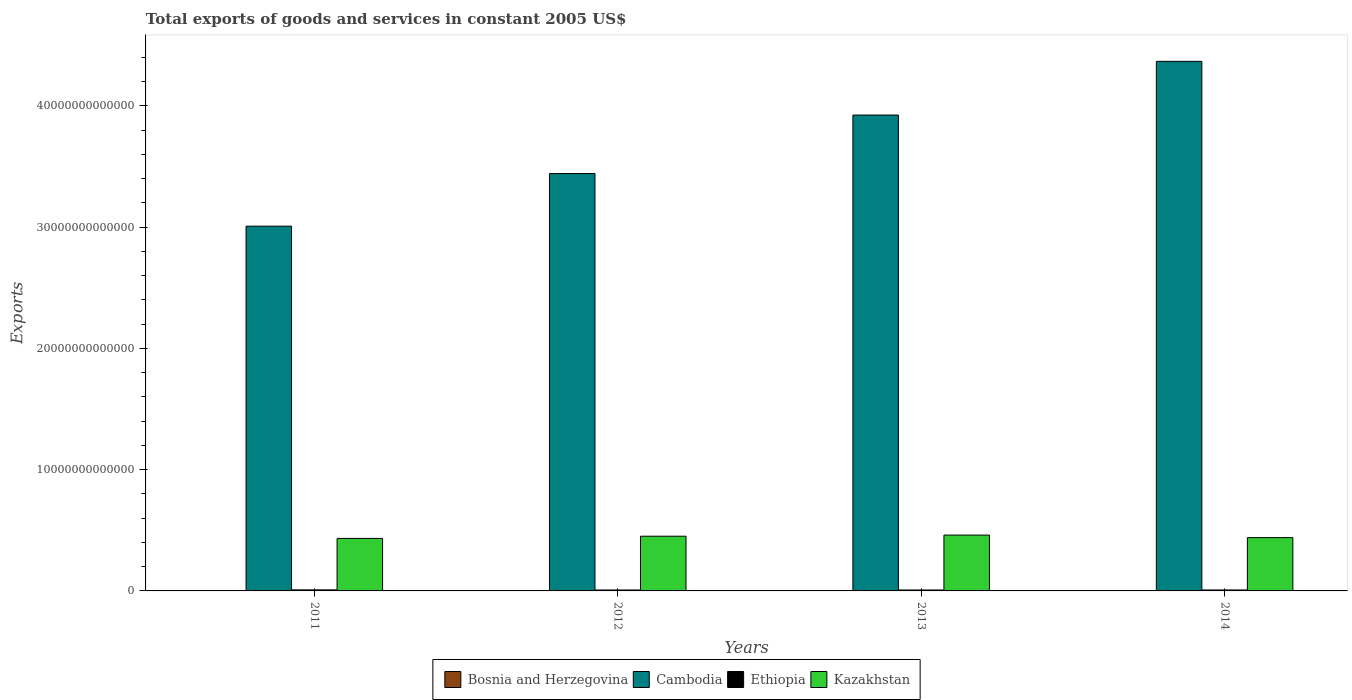How many different coloured bars are there?
Keep it short and to the point. 4. How many groups of bars are there?
Give a very brief answer. 4. Are the number of bars per tick equal to the number of legend labels?
Provide a short and direct response. Yes. How many bars are there on the 2nd tick from the right?
Make the answer very short. 4. What is the total exports of goods and services in Kazakhstan in 2012?
Make the answer very short. 4.51e+12. Across all years, what is the maximum total exports of goods and services in Bosnia and Herzegovina?
Offer a terse response. 8.82e+09. Across all years, what is the minimum total exports of goods and services in Ethiopia?
Your answer should be compact. 7.70e+1. In which year was the total exports of goods and services in Cambodia maximum?
Offer a terse response. 2014. In which year was the total exports of goods and services in Bosnia and Herzegovina minimum?
Your answer should be very brief. 2012. What is the total total exports of goods and services in Bosnia and Herzegovina in the graph?
Give a very brief answer. 3.30e+1. What is the difference between the total exports of goods and services in Cambodia in 2012 and that in 2013?
Your answer should be very brief. -4.83e+12. What is the difference between the total exports of goods and services in Ethiopia in 2012 and the total exports of goods and services in Cambodia in 2013?
Give a very brief answer. -3.92e+13. What is the average total exports of goods and services in Ethiopia per year?
Provide a short and direct response. 7.99e+1. In the year 2013, what is the difference between the total exports of goods and services in Bosnia and Herzegovina and total exports of goods and services in Kazakhstan?
Make the answer very short. -4.60e+12. What is the ratio of the total exports of goods and services in Bosnia and Herzegovina in 2011 to that in 2013?
Keep it short and to the point. 0.93. Is the total exports of goods and services in Ethiopia in 2013 less than that in 2014?
Offer a very short reply. Yes. Is the difference between the total exports of goods and services in Bosnia and Herzegovina in 2011 and 2014 greater than the difference between the total exports of goods and services in Kazakhstan in 2011 and 2014?
Keep it short and to the point. Yes. What is the difference between the highest and the second highest total exports of goods and services in Ethiopia?
Make the answer very short. 6.50e+09. What is the difference between the highest and the lowest total exports of goods and services in Kazakhstan?
Make the answer very short. 2.77e+11. In how many years, is the total exports of goods and services in Ethiopia greater than the average total exports of goods and services in Ethiopia taken over all years?
Provide a succinct answer. 1. Is the sum of the total exports of goods and services in Kazakhstan in 2011 and 2014 greater than the maximum total exports of goods and services in Cambodia across all years?
Your answer should be compact. No. What does the 2nd bar from the left in 2012 represents?
Keep it short and to the point. Cambodia. What does the 4th bar from the right in 2012 represents?
Keep it short and to the point. Bosnia and Herzegovina. Is it the case that in every year, the sum of the total exports of goods and services in Bosnia and Herzegovina and total exports of goods and services in Ethiopia is greater than the total exports of goods and services in Kazakhstan?
Make the answer very short. No. How many bars are there?
Your answer should be compact. 16. Are all the bars in the graph horizontal?
Your response must be concise. No. How many years are there in the graph?
Offer a terse response. 4. What is the difference between two consecutive major ticks on the Y-axis?
Provide a short and direct response. 1.00e+13. Does the graph contain any zero values?
Your answer should be very brief. No. Where does the legend appear in the graph?
Provide a succinct answer. Bottom center. How are the legend labels stacked?
Provide a short and direct response. Horizontal. What is the title of the graph?
Offer a terse response. Total exports of goods and services in constant 2005 US$. What is the label or title of the X-axis?
Your answer should be very brief. Years. What is the label or title of the Y-axis?
Offer a very short reply. Exports. What is the Exports in Bosnia and Herzegovina in 2011?
Offer a terse response. 7.88e+09. What is the Exports of Cambodia in 2011?
Your response must be concise. 3.01e+13. What is the Exports in Ethiopia in 2011?
Ensure brevity in your answer.  8.60e+1. What is the Exports of Kazakhstan in 2011?
Make the answer very short. 4.33e+12. What is the Exports of Bosnia and Herzegovina in 2012?
Offer a terse response. 7.84e+09. What is the Exports in Cambodia in 2012?
Keep it short and to the point. 3.44e+13. What is the Exports in Ethiopia in 2012?
Offer a very short reply. 7.70e+1. What is the Exports in Kazakhstan in 2012?
Your answer should be compact. 4.51e+12. What is the Exports of Bosnia and Herzegovina in 2013?
Your response must be concise. 8.46e+09. What is the Exports in Cambodia in 2013?
Offer a terse response. 3.92e+13. What is the Exports of Ethiopia in 2013?
Your answer should be very brief. 7.73e+1. What is the Exports of Kazakhstan in 2013?
Your answer should be very brief. 4.61e+12. What is the Exports in Bosnia and Herzegovina in 2014?
Offer a very short reply. 8.82e+09. What is the Exports of Cambodia in 2014?
Make the answer very short. 4.37e+13. What is the Exports in Ethiopia in 2014?
Your answer should be very brief. 7.94e+1. What is the Exports of Kazakhstan in 2014?
Keep it short and to the point. 4.39e+12. Across all years, what is the maximum Exports of Bosnia and Herzegovina?
Provide a succinct answer. 8.82e+09. Across all years, what is the maximum Exports in Cambodia?
Your response must be concise. 4.37e+13. Across all years, what is the maximum Exports in Ethiopia?
Provide a succinct answer. 8.60e+1. Across all years, what is the maximum Exports in Kazakhstan?
Make the answer very short. 4.61e+12. Across all years, what is the minimum Exports of Bosnia and Herzegovina?
Provide a succinct answer. 7.84e+09. Across all years, what is the minimum Exports in Cambodia?
Keep it short and to the point. 3.01e+13. Across all years, what is the minimum Exports of Ethiopia?
Give a very brief answer. 7.70e+1. Across all years, what is the minimum Exports in Kazakhstan?
Your answer should be very brief. 4.33e+12. What is the total Exports of Bosnia and Herzegovina in the graph?
Offer a terse response. 3.30e+1. What is the total Exports of Cambodia in the graph?
Your answer should be very brief. 1.47e+14. What is the total Exports of Ethiopia in the graph?
Keep it short and to the point. 3.20e+11. What is the total Exports in Kazakhstan in the graph?
Provide a succinct answer. 1.78e+13. What is the difference between the Exports of Bosnia and Herzegovina in 2011 and that in 2012?
Your answer should be very brief. 3.99e+07. What is the difference between the Exports of Cambodia in 2011 and that in 2012?
Make the answer very short. -4.34e+12. What is the difference between the Exports of Ethiopia in 2011 and that in 2012?
Ensure brevity in your answer.  8.91e+09. What is the difference between the Exports in Kazakhstan in 2011 and that in 2012?
Offer a terse response. -1.82e+11. What is the difference between the Exports in Bosnia and Herzegovina in 2011 and that in 2013?
Provide a succinct answer. -5.81e+08. What is the difference between the Exports of Cambodia in 2011 and that in 2013?
Ensure brevity in your answer.  -9.16e+12. What is the difference between the Exports of Ethiopia in 2011 and that in 2013?
Make the answer very short. 8.69e+09. What is the difference between the Exports of Kazakhstan in 2011 and that in 2013?
Your response must be concise. -2.77e+11. What is the difference between the Exports in Bosnia and Herzegovina in 2011 and that in 2014?
Provide a succinct answer. -9.36e+08. What is the difference between the Exports of Cambodia in 2011 and that in 2014?
Ensure brevity in your answer.  -1.36e+13. What is the difference between the Exports in Ethiopia in 2011 and that in 2014?
Your response must be concise. 6.50e+09. What is the difference between the Exports of Kazakhstan in 2011 and that in 2014?
Make the answer very short. -6.47e+1. What is the difference between the Exports in Bosnia and Herzegovina in 2012 and that in 2013?
Keep it short and to the point. -6.20e+08. What is the difference between the Exports of Cambodia in 2012 and that in 2013?
Offer a terse response. -4.83e+12. What is the difference between the Exports in Ethiopia in 2012 and that in 2013?
Provide a short and direct response. -2.12e+08. What is the difference between the Exports in Kazakhstan in 2012 and that in 2013?
Your answer should be very brief. -9.47e+1. What is the difference between the Exports of Bosnia and Herzegovina in 2012 and that in 2014?
Your response must be concise. -9.76e+08. What is the difference between the Exports of Cambodia in 2012 and that in 2014?
Provide a short and direct response. -9.25e+12. What is the difference between the Exports of Ethiopia in 2012 and that in 2014?
Provide a succinct answer. -2.40e+09. What is the difference between the Exports in Kazakhstan in 2012 and that in 2014?
Make the answer very short. 1.17e+11. What is the difference between the Exports of Bosnia and Herzegovina in 2013 and that in 2014?
Keep it short and to the point. -3.55e+08. What is the difference between the Exports of Cambodia in 2013 and that in 2014?
Ensure brevity in your answer.  -4.43e+12. What is the difference between the Exports of Ethiopia in 2013 and that in 2014?
Keep it short and to the point. -2.19e+09. What is the difference between the Exports in Kazakhstan in 2013 and that in 2014?
Give a very brief answer. 2.12e+11. What is the difference between the Exports of Bosnia and Herzegovina in 2011 and the Exports of Cambodia in 2012?
Offer a terse response. -3.44e+13. What is the difference between the Exports in Bosnia and Herzegovina in 2011 and the Exports in Ethiopia in 2012?
Make the answer very short. -6.92e+1. What is the difference between the Exports in Bosnia and Herzegovina in 2011 and the Exports in Kazakhstan in 2012?
Your answer should be compact. -4.50e+12. What is the difference between the Exports in Cambodia in 2011 and the Exports in Ethiopia in 2012?
Offer a very short reply. 3.00e+13. What is the difference between the Exports of Cambodia in 2011 and the Exports of Kazakhstan in 2012?
Make the answer very short. 2.56e+13. What is the difference between the Exports of Ethiopia in 2011 and the Exports of Kazakhstan in 2012?
Your response must be concise. -4.42e+12. What is the difference between the Exports of Bosnia and Herzegovina in 2011 and the Exports of Cambodia in 2013?
Provide a short and direct response. -3.92e+13. What is the difference between the Exports in Bosnia and Herzegovina in 2011 and the Exports in Ethiopia in 2013?
Ensure brevity in your answer.  -6.94e+1. What is the difference between the Exports in Bosnia and Herzegovina in 2011 and the Exports in Kazakhstan in 2013?
Your answer should be very brief. -4.60e+12. What is the difference between the Exports in Cambodia in 2011 and the Exports in Ethiopia in 2013?
Your response must be concise. 3.00e+13. What is the difference between the Exports of Cambodia in 2011 and the Exports of Kazakhstan in 2013?
Ensure brevity in your answer.  2.55e+13. What is the difference between the Exports of Ethiopia in 2011 and the Exports of Kazakhstan in 2013?
Give a very brief answer. -4.52e+12. What is the difference between the Exports of Bosnia and Herzegovina in 2011 and the Exports of Cambodia in 2014?
Your response must be concise. -4.37e+13. What is the difference between the Exports of Bosnia and Herzegovina in 2011 and the Exports of Ethiopia in 2014?
Offer a terse response. -7.16e+1. What is the difference between the Exports in Bosnia and Herzegovina in 2011 and the Exports in Kazakhstan in 2014?
Your answer should be very brief. -4.39e+12. What is the difference between the Exports in Cambodia in 2011 and the Exports in Ethiopia in 2014?
Keep it short and to the point. 3.00e+13. What is the difference between the Exports in Cambodia in 2011 and the Exports in Kazakhstan in 2014?
Ensure brevity in your answer.  2.57e+13. What is the difference between the Exports in Ethiopia in 2011 and the Exports in Kazakhstan in 2014?
Your response must be concise. -4.31e+12. What is the difference between the Exports of Bosnia and Herzegovina in 2012 and the Exports of Cambodia in 2013?
Ensure brevity in your answer.  -3.92e+13. What is the difference between the Exports in Bosnia and Herzegovina in 2012 and the Exports in Ethiopia in 2013?
Ensure brevity in your answer.  -6.94e+1. What is the difference between the Exports of Bosnia and Herzegovina in 2012 and the Exports of Kazakhstan in 2013?
Ensure brevity in your answer.  -4.60e+12. What is the difference between the Exports in Cambodia in 2012 and the Exports in Ethiopia in 2013?
Offer a very short reply. 3.43e+13. What is the difference between the Exports in Cambodia in 2012 and the Exports in Kazakhstan in 2013?
Keep it short and to the point. 2.98e+13. What is the difference between the Exports of Ethiopia in 2012 and the Exports of Kazakhstan in 2013?
Offer a very short reply. -4.53e+12. What is the difference between the Exports in Bosnia and Herzegovina in 2012 and the Exports in Cambodia in 2014?
Give a very brief answer. -4.37e+13. What is the difference between the Exports in Bosnia and Herzegovina in 2012 and the Exports in Ethiopia in 2014?
Your answer should be compact. -7.16e+1. What is the difference between the Exports of Bosnia and Herzegovina in 2012 and the Exports of Kazakhstan in 2014?
Your answer should be compact. -4.39e+12. What is the difference between the Exports in Cambodia in 2012 and the Exports in Ethiopia in 2014?
Your answer should be very brief. 3.43e+13. What is the difference between the Exports in Cambodia in 2012 and the Exports in Kazakhstan in 2014?
Make the answer very short. 3.00e+13. What is the difference between the Exports of Ethiopia in 2012 and the Exports of Kazakhstan in 2014?
Offer a very short reply. -4.32e+12. What is the difference between the Exports of Bosnia and Herzegovina in 2013 and the Exports of Cambodia in 2014?
Give a very brief answer. -4.37e+13. What is the difference between the Exports of Bosnia and Herzegovina in 2013 and the Exports of Ethiopia in 2014?
Provide a short and direct response. -7.10e+1. What is the difference between the Exports of Bosnia and Herzegovina in 2013 and the Exports of Kazakhstan in 2014?
Give a very brief answer. -4.39e+12. What is the difference between the Exports of Cambodia in 2013 and the Exports of Ethiopia in 2014?
Your response must be concise. 3.92e+13. What is the difference between the Exports in Cambodia in 2013 and the Exports in Kazakhstan in 2014?
Your answer should be very brief. 3.48e+13. What is the difference between the Exports of Ethiopia in 2013 and the Exports of Kazakhstan in 2014?
Keep it short and to the point. -4.32e+12. What is the average Exports of Bosnia and Herzegovina per year?
Your answer should be very brief. 8.25e+09. What is the average Exports in Cambodia per year?
Your answer should be compact. 3.68e+13. What is the average Exports of Ethiopia per year?
Offer a terse response. 7.99e+1. What is the average Exports in Kazakhstan per year?
Your answer should be compact. 4.46e+12. In the year 2011, what is the difference between the Exports of Bosnia and Herzegovina and Exports of Cambodia?
Provide a succinct answer. -3.01e+13. In the year 2011, what is the difference between the Exports in Bosnia and Herzegovina and Exports in Ethiopia?
Your answer should be compact. -7.81e+1. In the year 2011, what is the difference between the Exports in Bosnia and Herzegovina and Exports in Kazakhstan?
Your answer should be very brief. -4.32e+12. In the year 2011, what is the difference between the Exports of Cambodia and Exports of Ethiopia?
Make the answer very short. 3.00e+13. In the year 2011, what is the difference between the Exports in Cambodia and Exports in Kazakhstan?
Make the answer very short. 2.57e+13. In the year 2011, what is the difference between the Exports of Ethiopia and Exports of Kazakhstan?
Give a very brief answer. -4.24e+12. In the year 2012, what is the difference between the Exports in Bosnia and Herzegovina and Exports in Cambodia?
Make the answer very short. -3.44e+13. In the year 2012, what is the difference between the Exports of Bosnia and Herzegovina and Exports of Ethiopia?
Provide a succinct answer. -6.92e+1. In the year 2012, what is the difference between the Exports in Bosnia and Herzegovina and Exports in Kazakhstan?
Offer a terse response. -4.50e+12. In the year 2012, what is the difference between the Exports of Cambodia and Exports of Ethiopia?
Offer a very short reply. 3.43e+13. In the year 2012, what is the difference between the Exports in Cambodia and Exports in Kazakhstan?
Give a very brief answer. 2.99e+13. In the year 2012, what is the difference between the Exports of Ethiopia and Exports of Kazakhstan?
Make the answer very short. -4.43e+12. In the year 2013, what is the difference between the Exports in Bosnia and Herzegovina and Exports in Cambodia?
Your answer should be very brief. -3.92e+13. In the year 2013, what is the difference between the Exports in Bosnia and Herzegovina and Exports in Ethiopia?
Offer a terse response. -6.88e+1. In the year 2013, what is the difference between the Exports of Bosnia and Herzegovina and Exports of Kazakhstan?
Your response must be concise. -4.60e+12. In the year 2013, what is the difference between the Exports in Cambodia and Exports in Ethiopia?
Your answer should be compact. 3.92e+13. In the year 2013, what is the difference between the Exports of Cambodia and Exports of Kazakhstan?
Provide a short and direct response. 3.46e+13. In the year 2013, what is the difference between the Exports of Ethiopia and Exports of Kazakhstan?
Make the answer very short. -4.53e+12. In the year 2014, what is the difference between the Exports in Bosnia and Herzegovina and Exports in Cambodia?
Provide a short and direct response. -4.37e+13. In the year 2014, what is the difference between the Exports of Bosnia and Herzegovina and Exports of Ethiopia?
Offer a terse response. -7.06e+1. In the year 2014, what is the difference between the Exports in Bosnia and Herzegovina and Exports in Kazakhstan?
Make the answer very short. -4.38e+12. In the year 2014, what is the difference between the Exports in Cambodia and Exports in Ethiopia?
Your answer should be very brief. 4.36e+13. In the year 2014, what is the difference between the Exports of Cambodia and Exports of Kazakhstan?
Make the answer very short. 3.93e+13. In the year 2014, what is the difference between the Exports of Ethiopia and Exports of Kazakhstan?
Provide a short and direct response. -4.31e+12. What is the ratio of the Exports of Bosnia and Herzegovina in 2011 to that in 2012?
Offer a very short reply. 1.01. What is the ratio of the Exports of Cambodia in 2011 to that in 2012?
Provide a short and direct response. 0.87. What is the ratio of the Exports in Ethiopia in 2011 to that in 2012?
Provide a succinct answer. 1.12. What is the ratio of the Exports in Kazakhstan in 2011 to that in 2012?
Provide a short and direct response. 0.96. What is the ratio of the Exports of Bosnia and Herzegovina in 2011 to that in 2013?
Offer a very short reply. 0.93. What is the ratio of the Exports of Cambodia in 2011 to that in 2013?
Provide a succinct answer. 0.77. What is the ratio of the Exports in Ethiopia in 2011 to that in 2013?
Make the answer very short. 1.11. What is the ratio of the Exports in Bosnia and Herzegovina in 2011 to that in 2014?
Offer a terse response. 0.89. What is the ratio of the Exports in Cambodia in 2011 to that in 2014?
Your answer should be very brief. 0.69. What is the ratio of the Exports in Ethiopia in 2011 to that in 2014?
Offer a very short reply. 1.08. What is the ratio of the Exports in Kazakhstan in 2011 to that in 2014?
Ensure brevity in your answer.  0.99. What is the ratio of the Exports in Bosnia and Herzegovina in 2012 to that in 2013?
Your answer should be compact. 0.93. What is the ratio of the Exports of Cambodia in 2012 to that in 2013?
Offer a very short reply. 0.88. What is the ratio of the Exports in Kazakhstan in 2012 to that in 2013?
Make the answer very short. 0.98. What is the ratio of the Exports in Bosnia and Herzegovina in 2012 to that in 2014?
Offer a terse response. 0.89. What is the ratio of the Exports in Cambodia in 2012 to that in 2014?
Keep it short and to the point. 0.79. What is the ratio of the Exports in Ethiopia in 2012 to that in 2014?
Provide a short and direct response. 0.97. What is the ratio of the Exports in Kazakhstan in 2012 to that in 2014?
Your answer should be compact. 1.03. What is the ratio of the Exports of Bosnia and Herzegovina in 2013 to that in 2014?
Provide a succinct answer. 0.96. What is the ratio of the Exports in Cambodia in 2013 to that in 2014?
Provide a succinct answer. 0.9. What is the ratio of the Exports in Ethiopia in 2013 to that in 2014?
Your answer should be compact. 0.97. What is the ratio of the Exports in Kazakhstan in 2013 to that in 2014?
Provide a short and direct response. 1.05. What is the difference between the highest and the second highest Exports in Bosnia and Herzegovina?
Offer a very short reply. 3.55e+08. What is the difference between the highest and the second highest Exports in Cambodia?
Offer a terse response. 4.43e+12. What is the difference between the highest and the second highest Exports of Ethiopia?
Your response must be concise. 6.50e+09. What is the difference between the highest and the second highest Exports in Kazakhstan?
Provide a short and direct response. 9.47e+1. What is the difference between the highest and the lowest Exports in Bosnia and Herzegovina?
Your response must be concise. 9.76e+08. What is the difference between the highest and the lowest Exports of Cambodia?
Your answer should be compact. 1.36e+13. What is the difference between the highest and the lowest Exports in Ethiopia?
Give a very brief answer. 8.91e+09. What is the difference between the highest and the lowest Exports in Kazakhstan?
Your answer should be very brief. 2.77e+11. 